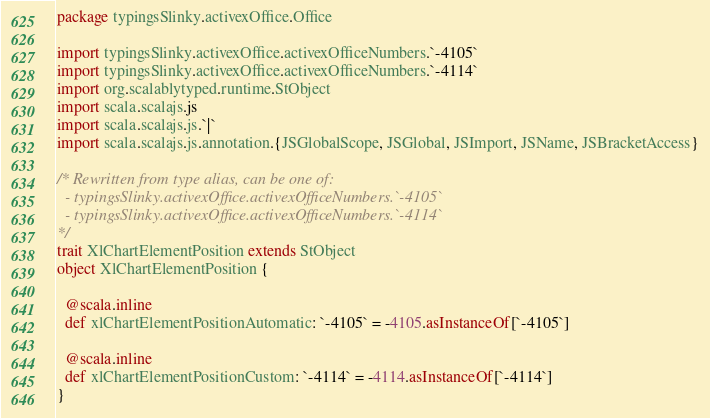<code> <loc_0><loc_0><loc_500><loc_500><_Scala_>package typingsSlinky.activexOffice.Office

import typingsSlinky.activexOffice.activexOfficeNumbers.`-4105`
import typingsSlinky.activexOffice.activexOfficeNumbers.`-4114`
import org.scalablytyped.runtime.StObject
import scala.scalajs.js
import scala.scalajs.js.`|`
import scala.scalajs.js.annotation.{JSGlobalScope, JSGlobal, JSImport, JSName, JSBracketAccess}

/* Rewritten from type alias, can be one of: 
  - typingsSlinky.activexOffice.activexOfficeNumbers.`-4105`
  - typingsSlinky.activexOffice.activexOfficeNumbers.`-4114`
*/
trait XlChartElementPosition extends StObject
object XlChartElementPosition {
  
  @scala.inline
  def xlChartElementPositionAutomatic: `-4105` = -4105.asInstanceOf[`-4105`]
  
  @scala.inline
  def xlChartElementPositionCustom: `-4114` = -4114.asInstanceOf[`-4114`]
}
</code> 